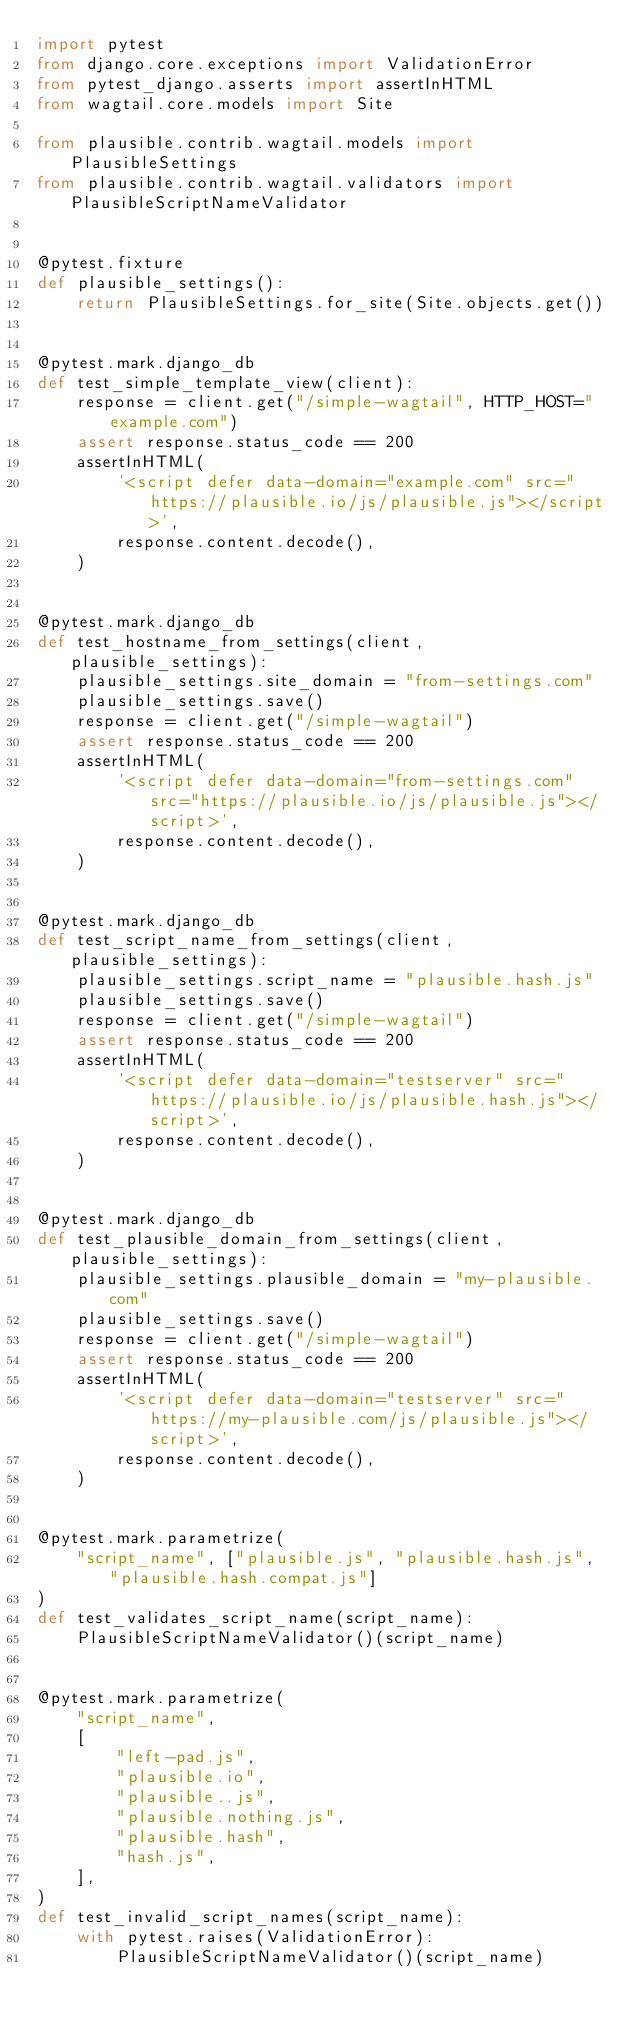<code> <loc_0><loc_0><loc_500><loc_500><_Python_>import pytest
from django.core.exceptions import ValidationError
from pytest_django.asserts import assertInHTML
from wagtail.core.models import Site

from plausible.contrib.wagtail.models import PlausibleSettings
from plausible.contrib.wagtail.validators import PlausibleScriptNameValidator


@pytest.fixture
def plausible_settings():
    return PlausibleSettings.for_site(Site.objects.get())


@pytest.mark.django_db
def test_simple_template_view(client):
    response = client.get("/simple-wagtail", HTTP_HOST="example.com")
    assert response.status_code == 200
    assertInHTML(
        '<script defer data-domain="example.com" src="https://plausible.io/js/plausible.js"></script>',
        response.content.decode(),
    )


@pytest.mark.django_db
def test_hostname_from_settings(client, plausible_settings):
    plausible_settings.site_domain = "from-settings.com"
    plausible_settings.save()
    response = client.get("/simple-wagtail")
    assert response.status_code == 200
    assertInHTML(
        '<script defer data-domain="from-settings.com" src="https://plausible.io/js/plausible.js"></script>',
        response.content.decode(),
    )


@pytest.mark.django_db
def test_script_name_from_settings(client, plausible_settings):
    plausible_settings.script_name = "plausible.hash.js"
    plausible_settings.save()
    response = client.get("/simple-wagtail")
    assert response.status_code == 200
    assertInHTML(
        '<script defer data-domain="testserver" src="https://plausible.io/js/plausible.hash.js"></script>',
        response.content.decode(),
    )


@pytest.mark.django_db
def test_plausible_domain_from_settings(client, plausible_settings):
    plausible_settings.plausible_domain = "my-plausible.com"
    plausible_settings.save()
    response = client.get("/simple-wagtail")
    assert response.status_code == 200
    assertInHTML(
        '<script defer data-domain="testserver" src="https://my-plausible.com/js/plausible.js"></script>',
        response.content.decode(),
    )


@pytest.mark.parametrize(
    "script_name", ["plausible.js", "plausible.hash.js", "plausible.hash.compat.js"]
)
def test_validates_script_name(script_name):
    PlausibleScriptNameValidator()(script_name)


@pytest.mark.parametrize(
    "script_name",
    [
        "left-pad.js",
        "plausible.io",
        "plausible..js",
        "plausible.nothing.js",
        "plausible.hash",
        "hash.js",
    ],
)
def test_invalid_script_names(script_name):
    with pytest.raises(ValidationError):
        PlausibleScriptNameValidator()(script_name)
</code> 